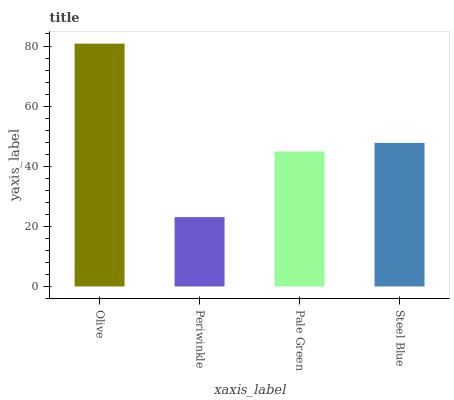Is Periwinkle the minimum?
Answer yes or no. Yes. Is Olive the maximum?
Answer yes or no. Yes. Is Pale Green the minimum?
Answer yes or no. No. Is Pale Green the maximum?
Answer yes or no. No. Is Pale Green greater than Periwinkle?
Answer yes or no. Yes. Is Periwinkle less than Pale Green?
Answer yes or no. Yes. Is Periwinkle greater than Pale Green?
Answer yes or no. No. Is Pale Green less than Periwinkle?
Answer yes or no. No. Is Steel Blue the high median?
Answer yes or no. Yes. Is Pale Green the low median?
Answer yes or no. Yes. Is Periwinkle the high median?
Answer yes or no. No. Is Periwinkle the low median?
Answer yes or no. No. 